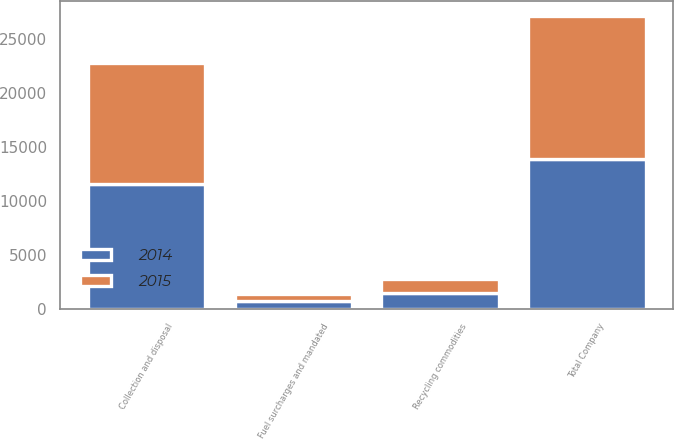Convert chart. <chart><loc_0><loc_0><loc_500><loc_500><stacked_bar_chart><ecel><fcel>Collection and disposal<fcel>Recycling commodities<fcel>Fuel surcharges and mandated<fcel>Total Company<nl><fcel>2015<fcel>11214<fcel>1331<fcel>689<fcel>13234<nl><fcel>2014<fcel>11512<fcel>1431<fcel>684<fcel>13893<nl></chart> 